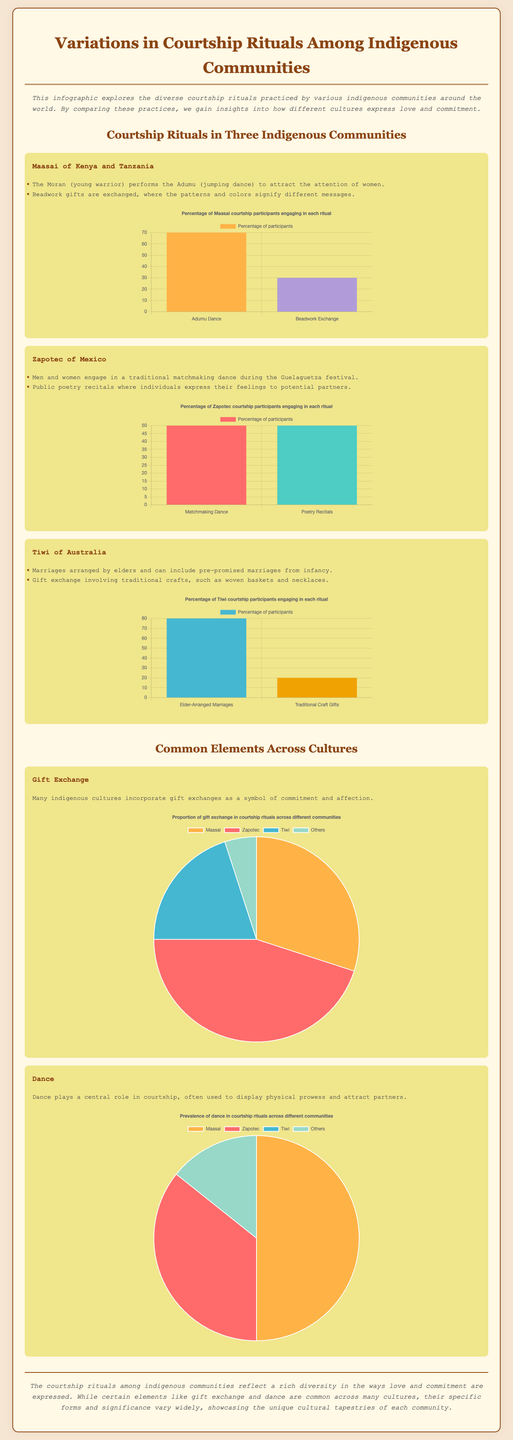what are the two courtship rituals practiced by the Maasai? The courtship rituals practiced by the Maasai are the Adumu (jumping dance) and beadwork gifts.
Answer: Adumu, beadwork gifts what percentage of Zapotec courtship participants engage in matchmaking dance? The Zapotec courtship participants engaging in matchmaking dance is illustrated in the bar graph, which shows 50%.
Answer: 50% which community has the highest percentage of participants engaging in elder-arranged marriages? The Tiwi community has the highest percentage of participants engaging in elder-arranged marriages at 80%.
Answer: 80% what color represents the Adumu dance in the Maasai chart? The color representing the Adumu dance in the Maasai chart is orange (#FFB347).
Answer: orange how many communities are compared in the common elements section? The common elements section compares gift exchange and dance among three communities: Maasai, Zapotec, and Tiwi.
Answer: two what is the total proportion of gift exchange in courtship rituals across Maasai, Zapotec, and Tiwi? The total proportion of gift exchange across the three communities is the sum of their percentages in the pie chart, which is 30% + 45% + 20% = 95%.
Answer: 95% what is the primary function of dance in courtship rituals as indicated in the document? Dance plays a central role in displaying physical prowess and attracting partners.
Answer: display physical prowess which community's courtship ritual does not involve dance? The Tiwi community's courtship ritual predominantly involves elder-arranged marriages that do not include dance.
Answer: Tiwi what type of chart is used to show the prevalence of dance in courtship rituals? A pie chart is used to show the prevalence of dance in courtship rituals.
Answer: pie chart 